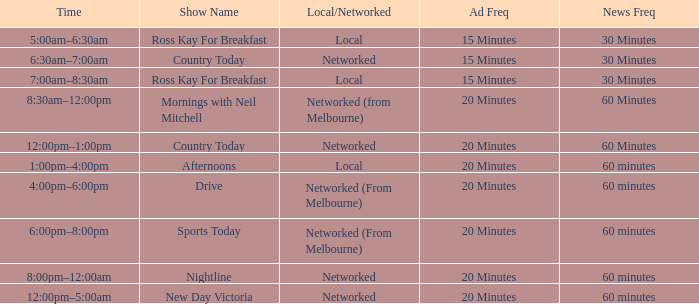What Local/Networked has a Show Name of nightline? Networked. 